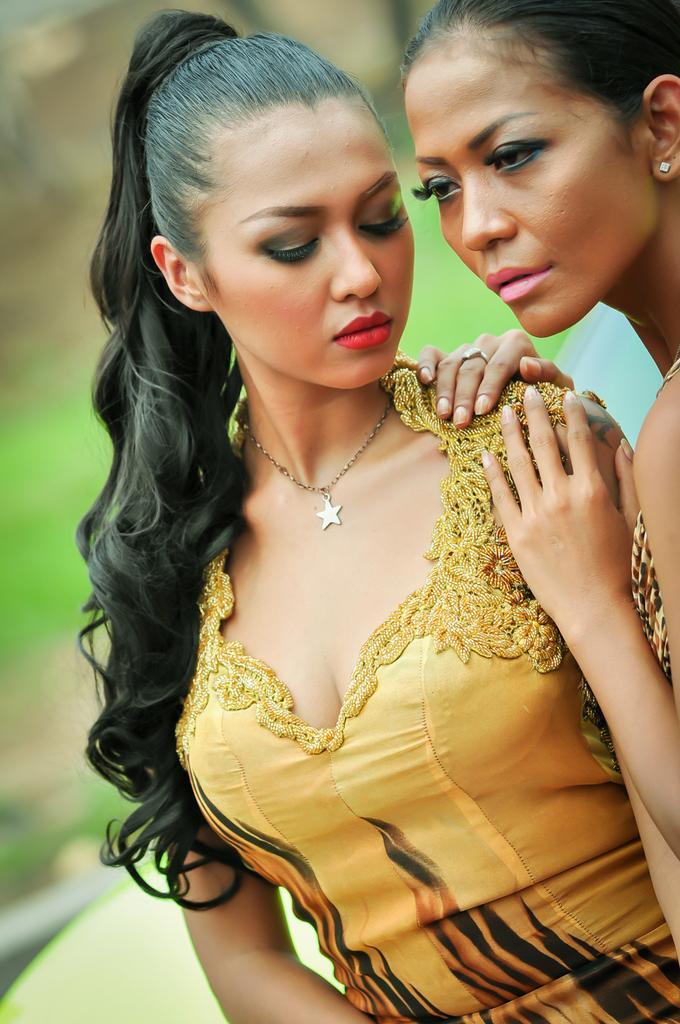Describe this image in one or two sentences. In this image I can see two women. They are giving pose for the picture. The woman who is on the right side is looking at the left side. The other woman who is on the left side is looking at the downwards. The background is blurred. 